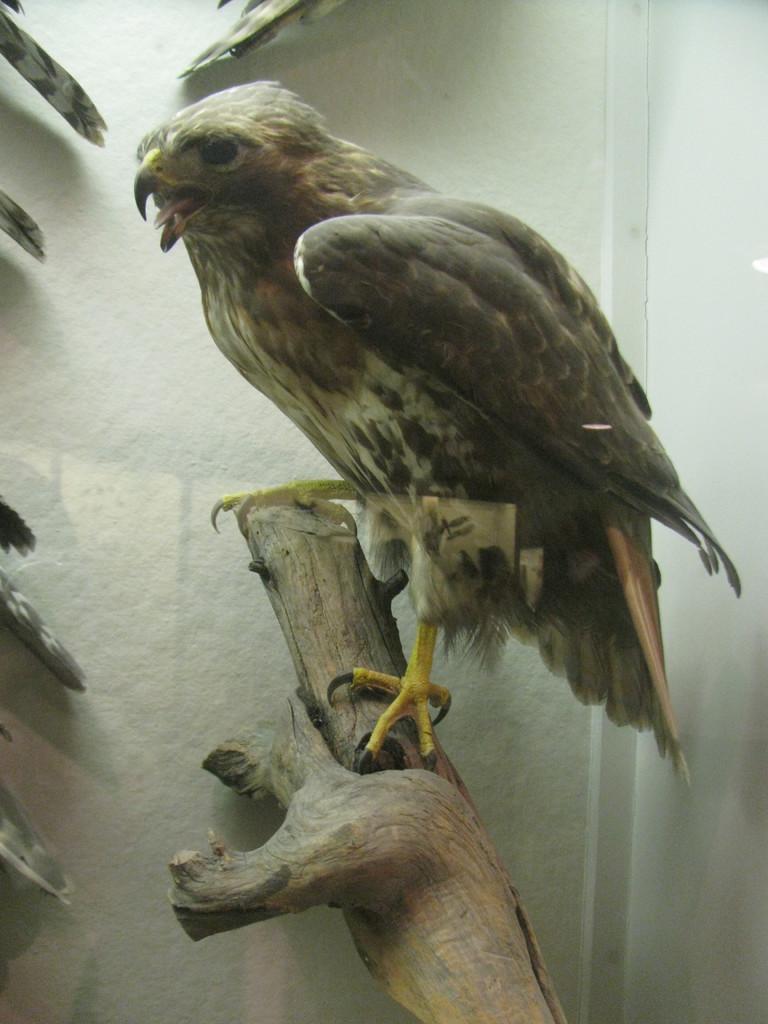Please provide a concise description of this image. In this image I can see tree trunk and on it I can see a grey colour bird. I can also see white colour wall in background. 